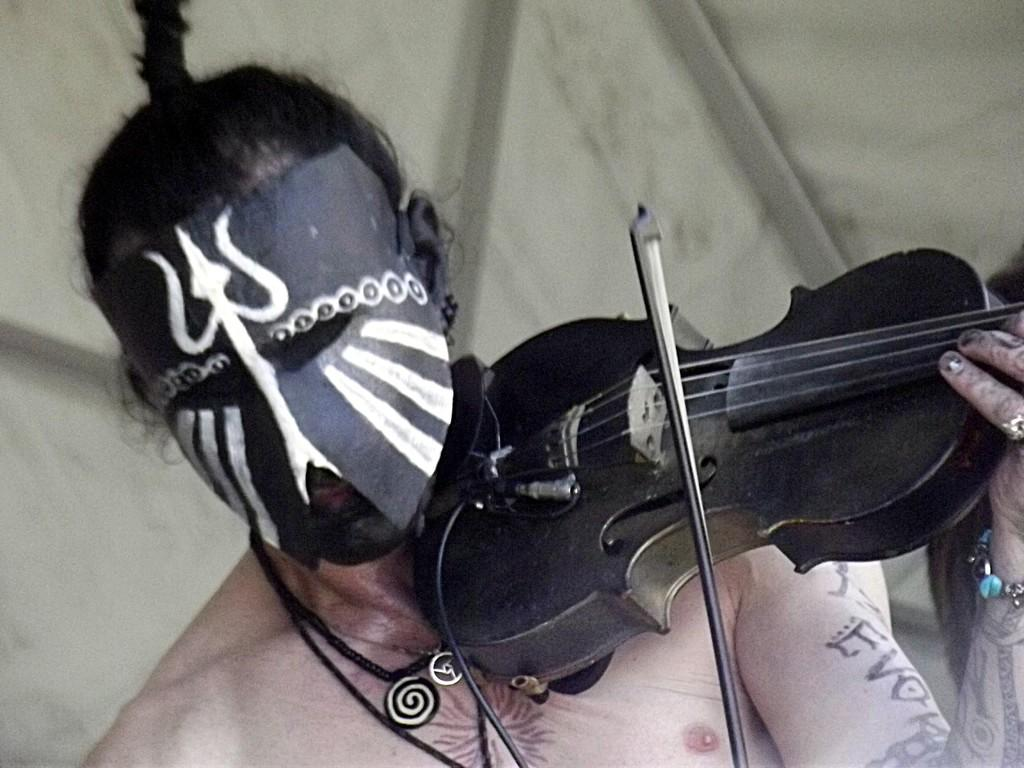Who or what is the main subject in the image? There is a person in the image. What is the person wearing? The person is wearing a mask. What is the person doing in the image? The person is playing a musical instrument. What can be seen in the background of the image? There is a curtain in the background of the image. What type of cracker is the person eating while playing the musical instrument in the image? There is no cracker present in the image, and the person is not eating anything while playing the musical instrument. 